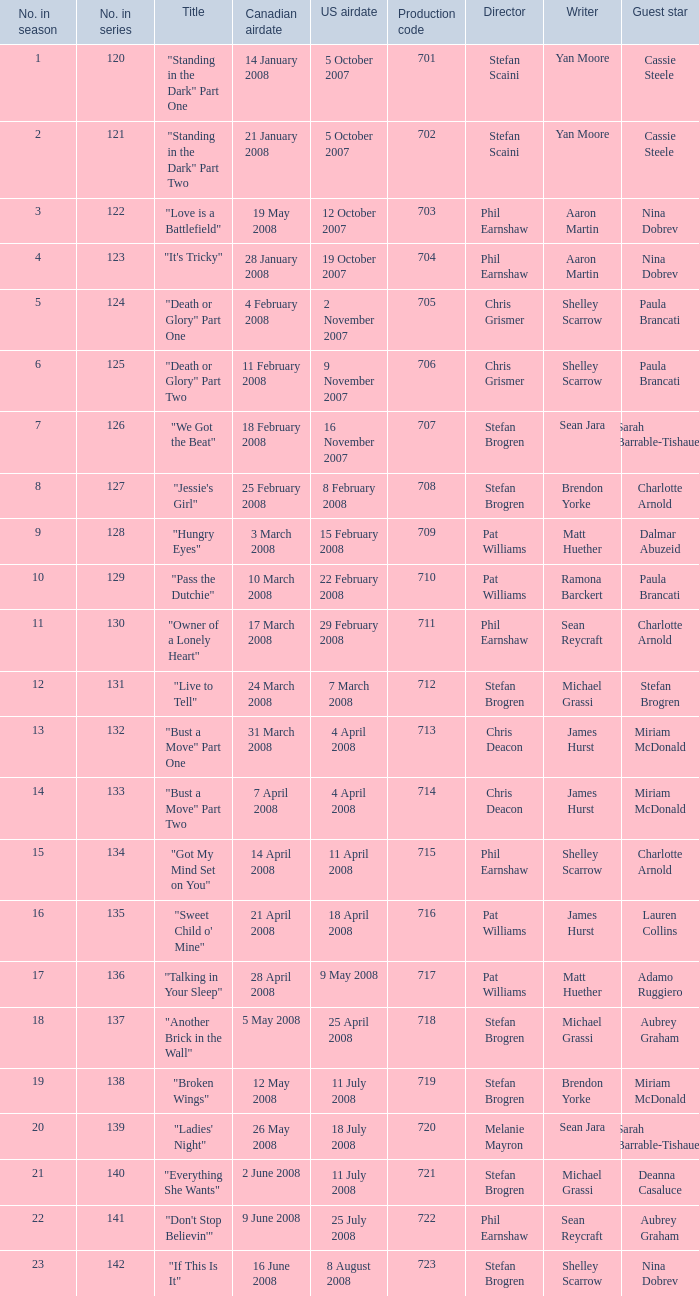The canadian airdate of 11 february 2008 applied to what series number? 1.0. 